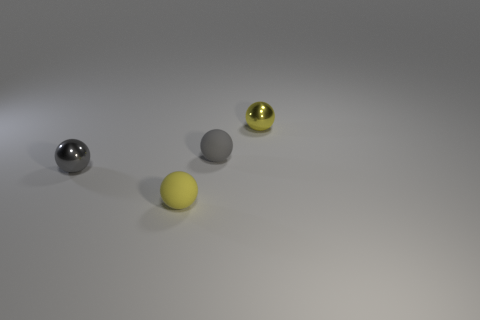Subtract all gray matte spheres. How many spheres are left? 3 Add 1 tiny gray things. How many objects exist? 5 Subtract all blue spheres. Subtract all purple blocks. How many spheres are left? 4 Subtract 2 yellow spheres. How many objects are left? 2 Subtract all tiny red metal cubes. Subtract all tiny gray objects. How many objects are left? 2 Add 3 tiny gray balls. How many tiny gray balls are left? 5 Add 2 small yellow rubber spheres. How many small yellow rubber spheres exist? 3 